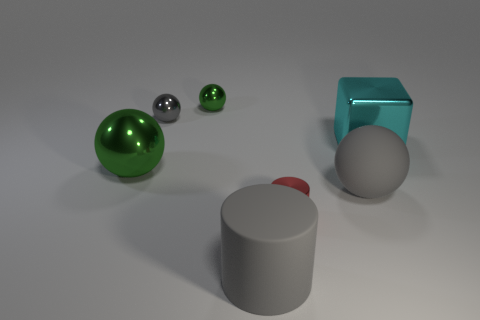There is a small metallic cylinder in front of the gray metallic sphere; what color is it?
Your response must be concise. Red. There is a green metallic ball in front of the big cyan metallic thing; is there a small red cylinder behind it?
Ensure brevity in your answer.  No. There is a big matte object that is in front of the tiny red shiny object; is its color the same as the metal sphere that is in front of the cyan shiny block?
Your answer should be very brief. No. What number of rubber things are behind the large gray rubber cylinder?
Keep it short and to the point. 1. What number of metallic objects are the same color as the large cylinder?
Ensure brevity in your answer.  1. Do the big cylinder that is in front of the large green shiny ball and the tiny red cylinder have the same material?
Provide a short and direct response. No. What number of green spheres have the same material as the red object?
Make the answer very short. 2. Are there more large cyan shiny blocks on the left side of the large green metal sphere than tiny brown metal objects?
Provide a short and direct response. No. There is a shiny sphere that is the same color as the big rubber cylinder; what is its size?
Make the answer very short. Small. Are there any small green objects of the same shape as the tiny red metallic thing?
Your answer should be compact. No. 